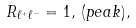<formula> <loc_0><loc_0><loc_500><loc_500>R _ { \ell ^ { + } \ell ^ { - } } = 1 , \, ( p e a k ) ,</formula> 